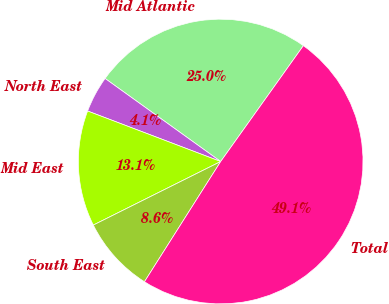<chart> <loc_0><loc_0><loc_500><loc_500><pie_chart><fcel>Mid Atlantic<fcel>North East<fcel>Mid East<fcel>South East<fcel>Total<nl><fcel>24.95%<fcel>4.14%<fcel>13.14%<fcel>8.64%<fcel>49.12%<nl></chart> 